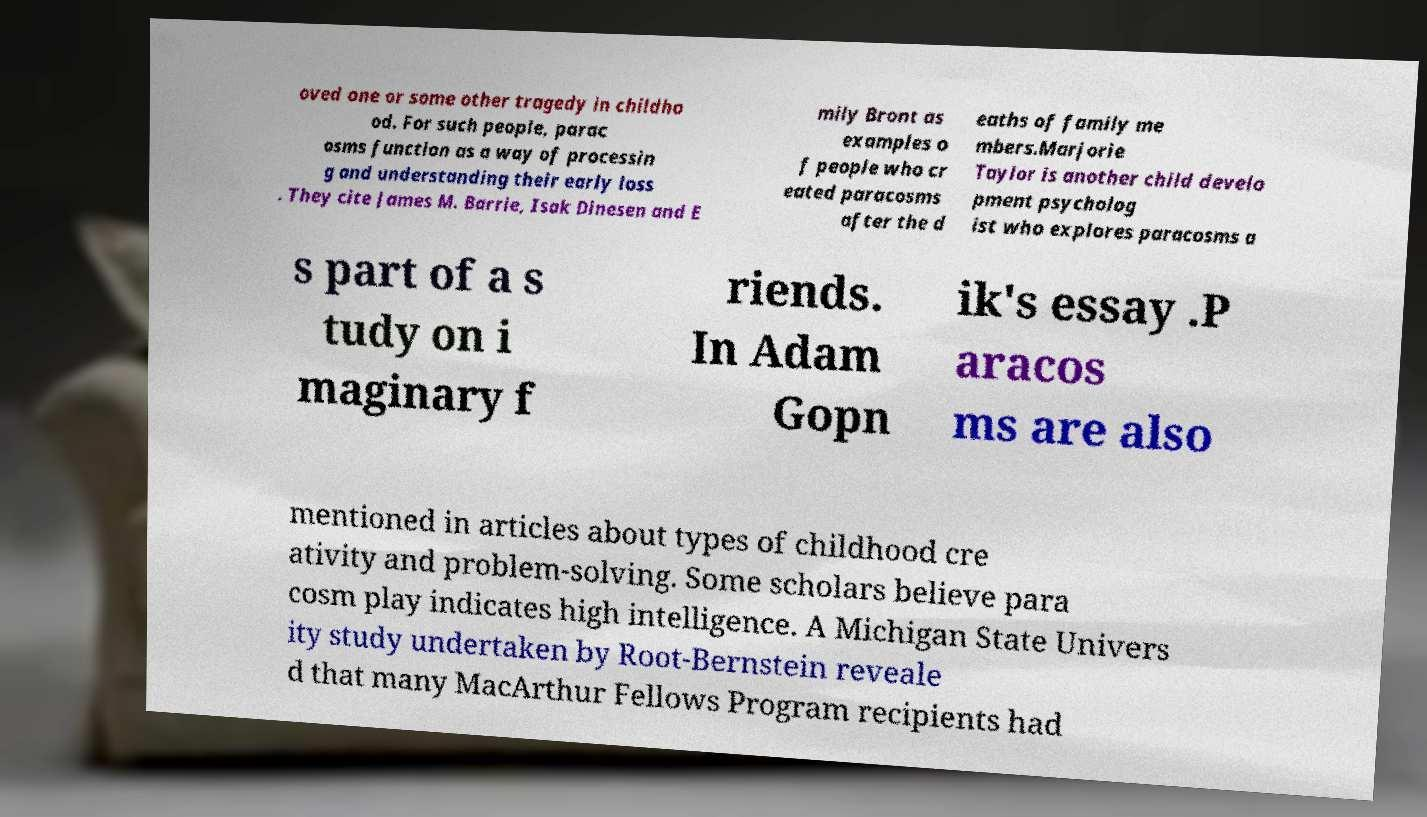What messages or text are displayed in this image? I need them in a readable, typed format. oved one or some other tragedy in childho od. For such people, parac osms function as a way of processin g and understanding their early loss . They cite James M. Barrie, Isak Dinesen and E mily Bront as examples o f people who cr eated paracosms after the d eaths of family me mbers.Marjorie Taylor is another child develo pment psycholog ist who explores paracosms a s part of a s tudy on i maginary f riends. In Adam Gopn ik's essay .P aracos ms are also mentioned in articles about types of childhood cre ativity and problem-solving. Some scholars believe para cosm play indicates high intelligence. A Michigan State Univers ity study undertaken by Root-Bernstein reveale d that many MacArthur Fellows Program recipients had 